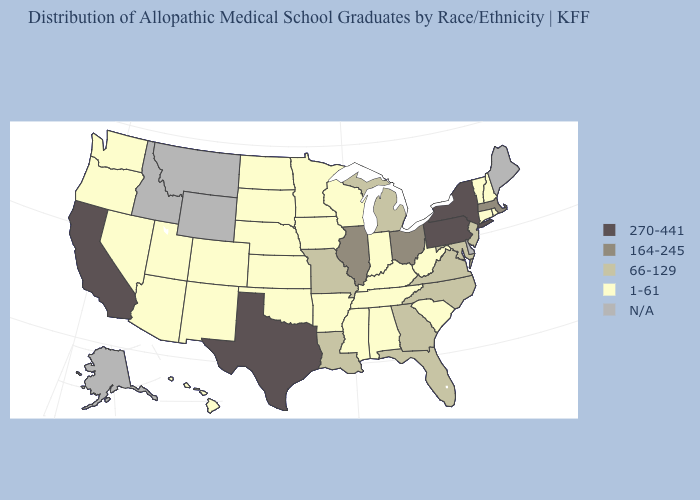What is the lowest value in the USA?
Quick response, please. 1-61. Name the states that have a value in the range 1-61?
Keep it brief. Alabama, Arizona, Arkansas, Colorado, Connecticut, Hawaii, Indiana, Iowa, Kansas, Kentucky, Minnesota, Mississippi, Nebraska, Nevada, New Hampshire, New Mexico, North Dakota, Oklahoma, Oregon, Rhode Island, South Carolina, South Dakota, Tennessee, Utah, Vermont, Washington, West Virginia, Wisconsin. Is the legend a continuous bar?
Answer briefly. No. Does Arkansas have the highest value in the USA?
Quick response, please. No. Does Alabama have the lowest value in the USA?
Concise answer only. Yes. What is the lowest value in the MidWest?
Concise answer only. 1-61. Does the first symbol in the legend represent the smallest category?
Be succinct. No. What is the value of Maine?
Write a very short answer. N/A. What is the lowest value in the USA?
Be succinct. 1-61. What is the value of Maryland?
Concise answer only. 66-129. How many symbols are there in the legend?
Write a very short answer. 5. What is the value of Rhode Island?
Give a very brief answer. 1-61. Does New York have the highest value in the Northeast?
Quick response, please. Yes. 